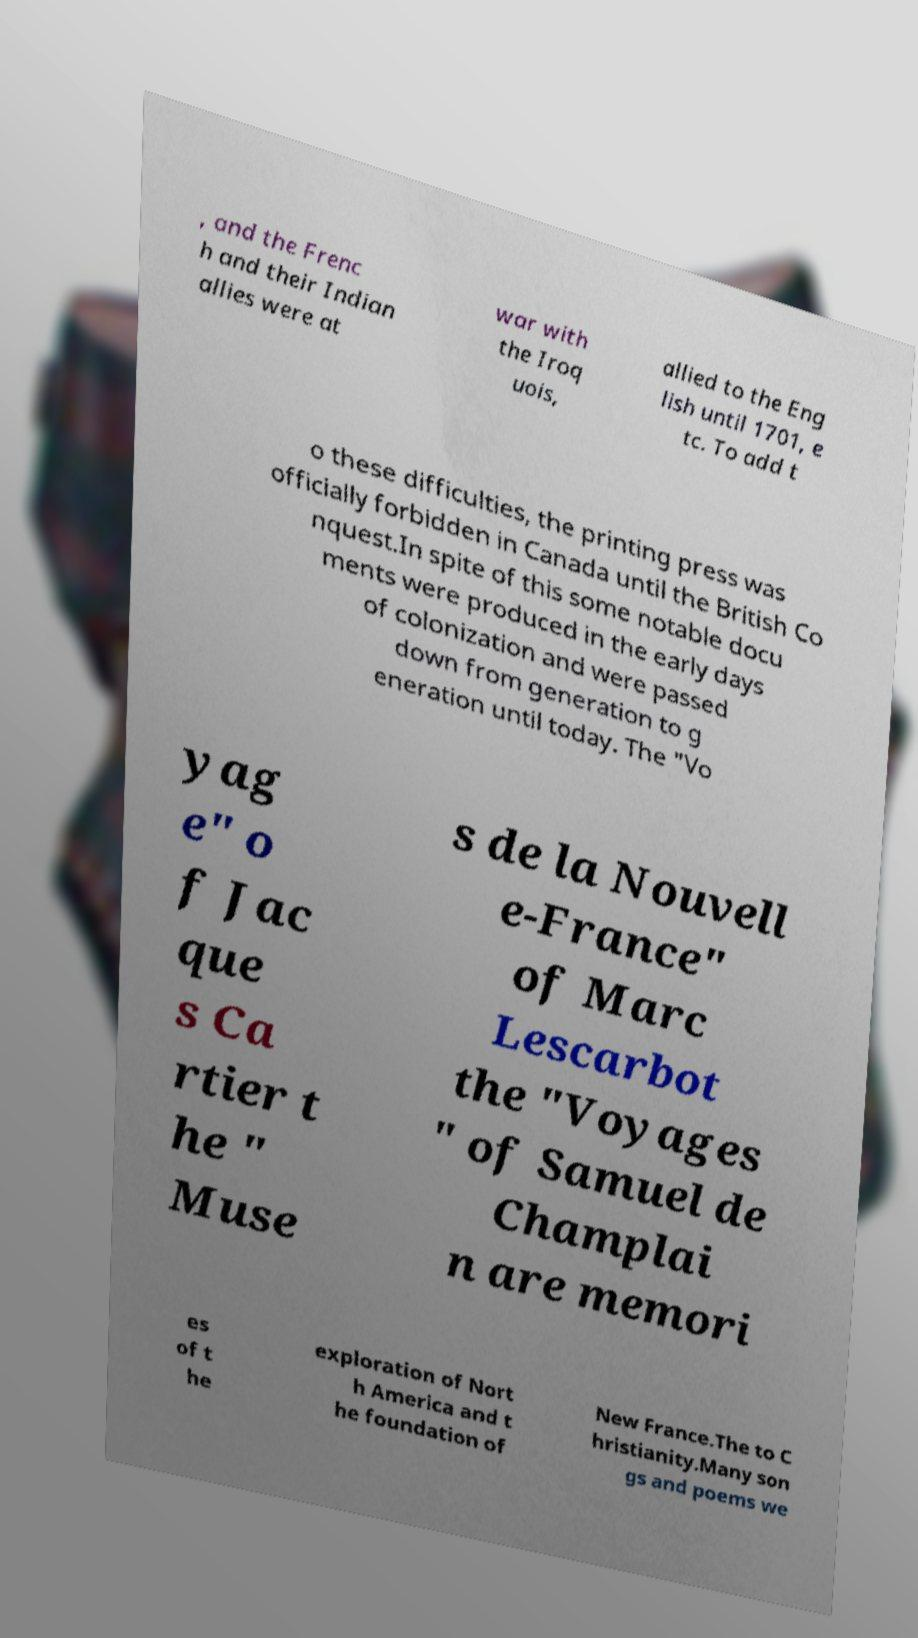There's text embedded in this image that I need extracted. Can you transcribe it verbatim? , and the Frenc h and their Indian allies were at war with the Iroq uois, allied to the Eng lish until 1701, e tc. To add t o these difficulties, the printing press was officially forbidden in Canada until the British Co nquest.In spite of this some notable docu ments were produced in the early days of colonization and were passed down from generation to g eneration until today. The "Vo yag e" o f Jac que s Ca rtier t he " Muse s de la Nouvell e-France" of Marc Lescarbot the "Voyages " of Samuel de Champlai n are memori es of t he exploration of Nort h America and t he foundation of New France.The to C hristianity.Many son gs and poems we 